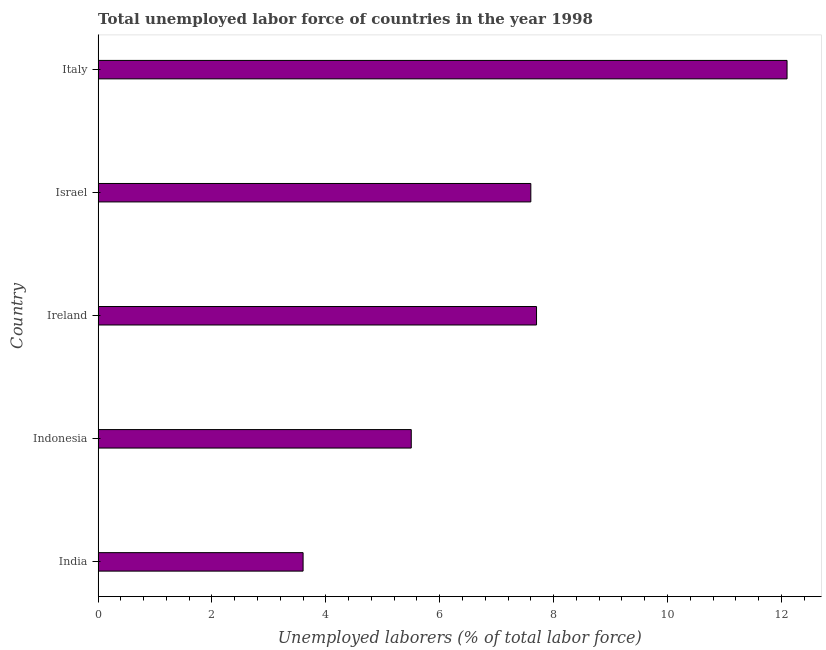Does the graph contain any zero values?
Provide a short and direct response. No. What is the title of the graph?
Provide a succinct answer. Total unemployed labor force of countries in the year 1998. What is the label or title of the X-axis?
Your answer should be very brief. Unemployed laborers (% of total labor force). What is the total unemployed labour force in Italy?
Keep it short and to the point. 12.1. Across all countries, what is the maximum total unemployed labour force?
Provide a short and direct response. 12.1. Across all countries, what is the minimum total unemployed labour force?
Offer a very short reply. 3.6. In which country was the total unemployed labour force maximum?
Your answer should be very brief. Italy. What is the sum of the total unemployed labour force?
Ensure brevity in your answer.  36.5. What is the difference between the total unemployed labour force in Indonesia and Israel?
Your answer should be very brief. -2.1. What is the median total unemployed labour force?
Provide a short and direct response. 7.6. What is the ratio of the total unemployed labour force in India to that in Indonesia?
Offer a terse response. 0.66. Is the total unemployed labour force in India less than that in Ireland?
Your answer should be very brief. Yes. Is the difference between the total unemployed labour force in Indonesia and Israel greater than the difference between any two countries?
Make the answer very short. No. What is the difference between the highest and the lowest total unemployed labour force?
Offer a terse response. 8.5. In how many countries, is the total unemployed labour force greater than the average total unemployed labour force taken over all countries?
Offer a terse response. 3. How many bars are there?
Your answer should be compact. 5. What is the difference between two consecutive major ticks on the X-axis?
Ensure brevity in your answer.  2. What is the Unemployed laborers (% of total labor force) in India?
Provide a succinct answer. 3.6. What is the Unemployed laborers (% of total labor force) of Ireland?
Your response must be concise. 7.7. What is the Unemployed laborers (% of total labor force) in Israel?
Provide a short and direct response. 7.6. What is the Unemployed laborers (% of total labor force) of Italy?
Provide a succinct answer. 12.1. What is the difference between the Unemployed laborers (% of total labor force) in India and Indonesia?
Keep it short and to the point. -1.9. What is the difference between the Unemployed laborers (% of total labor force) in India and Ireland?
Keep it short and to the point. -4.1. What is the difference between the Unemployed laborers (% of total labor force) in India and Italy?
Provide a succinct answer. -8.5. What is the difference between the Unemployed laborers (% of total labor force) in Indonesia and Israel?
Your answer should be compact. -2.1. What is the difference between the Unemployed laborers (% of total labor force) in Israel and Italy?
Ensure brevity in your answer.  -4.5. What is the ratio of the Unemployed laborers (% of total labor force) in India to that in Indonesia?
Offer a terse response. 0.66. What is the ratio of the Unemployed laborers (% of total labor force) in India to that in Ireland?
Provide a short and direct response. 0.47. What is the ratio of the Unemployed laborers (% of total labor force) in India to that in Israel?
Keep it short and to the point. 0.47. What is the ratio of the Unemployed laborers (% of total labor force) in India to that in Italy?
Offer a very short reply. 0.3. What is the ratio of the Unemployed laborers (% of total labor force) in Indonesia to that in Ireland?
Offer a terse response. 0.71. What is the ratio of the Unemployed laborers (% of total labor force) in Indonesia to that in Israel?
Your response must be concise. 0.72. What is the ratio of the Unemployed laborers (% of total labor force) in Indonesia to that in Italy?
Your answer should be compact. 0.46. What is the ratio of the Unemployed laborers (% of total labor force) in Ireland to that in Italy?
Your response must be concise. 0.64. What is the ratio of the Unemployed laborers (% of total labor force) in Israel to that in Italy?
Offer a very short reply. 0.63. 